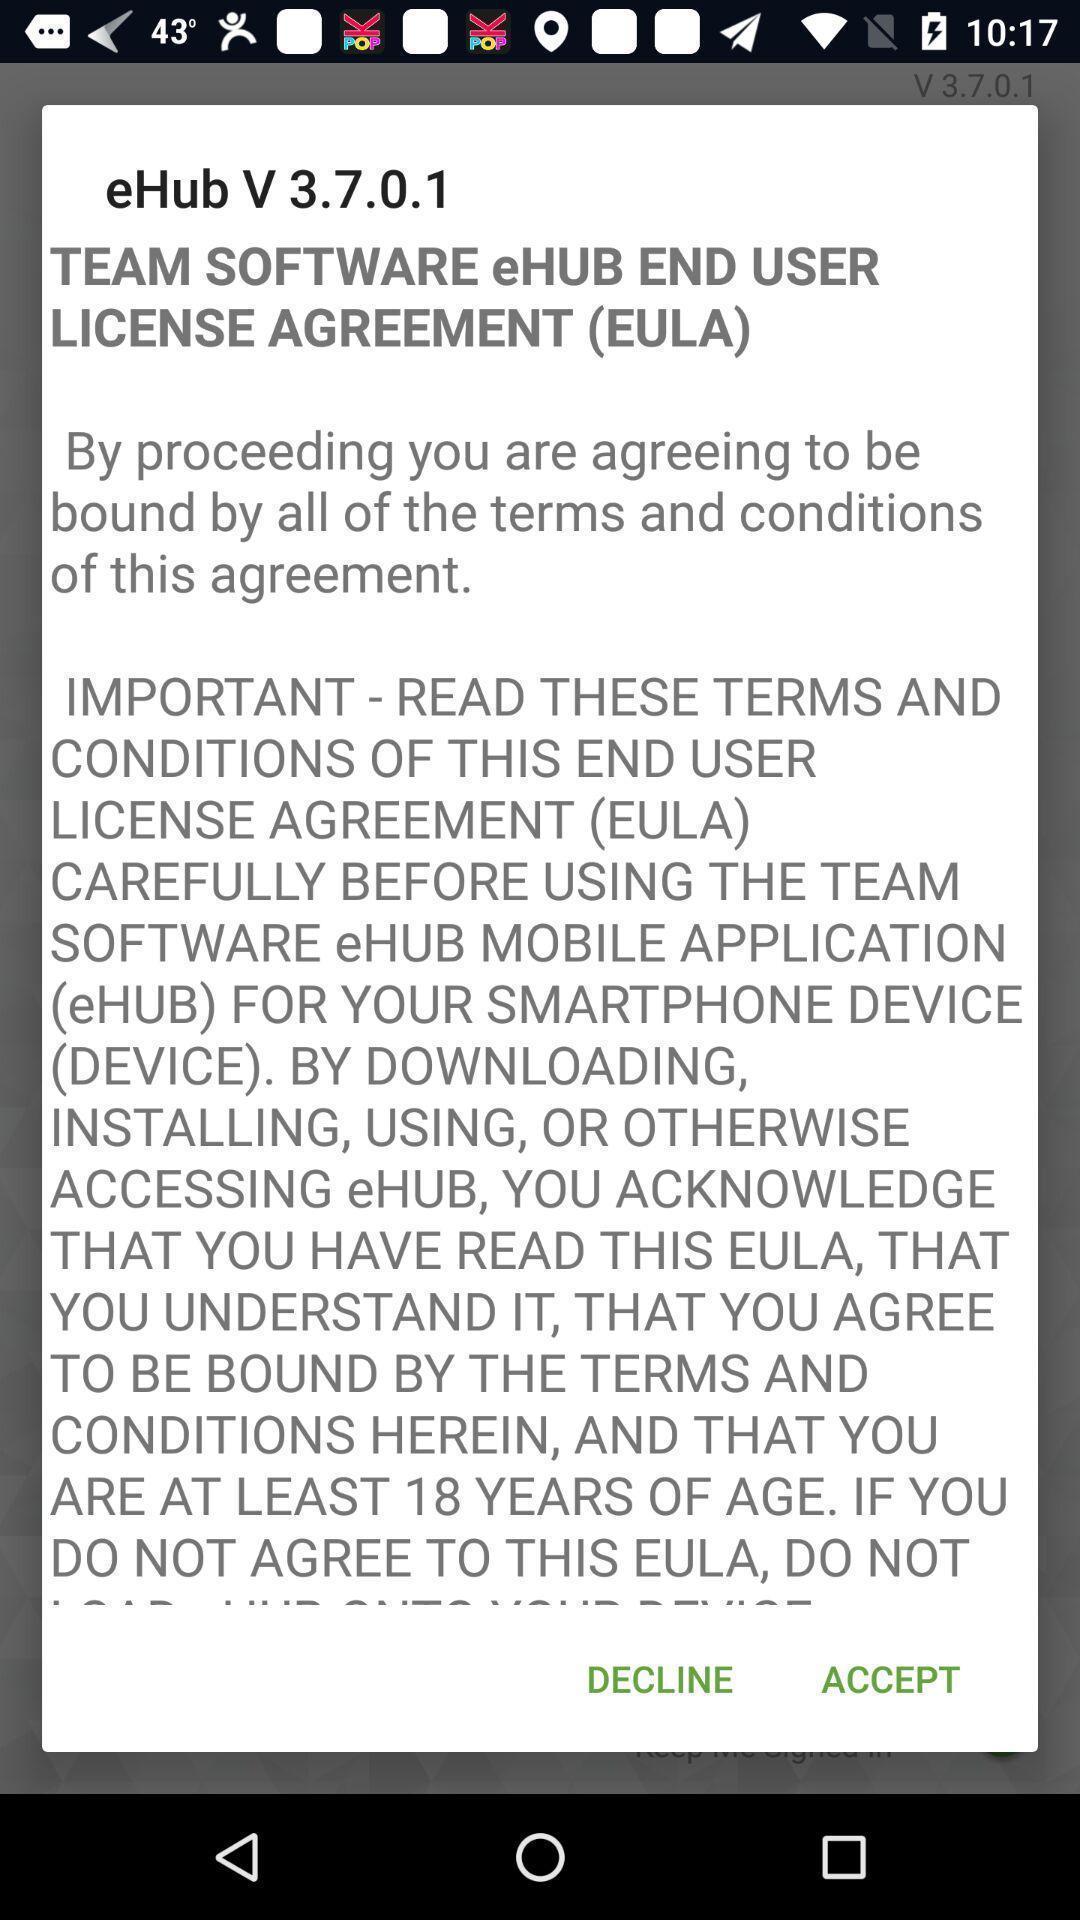What details can you identify in this image? Pop-up showing to accept license agreement. 